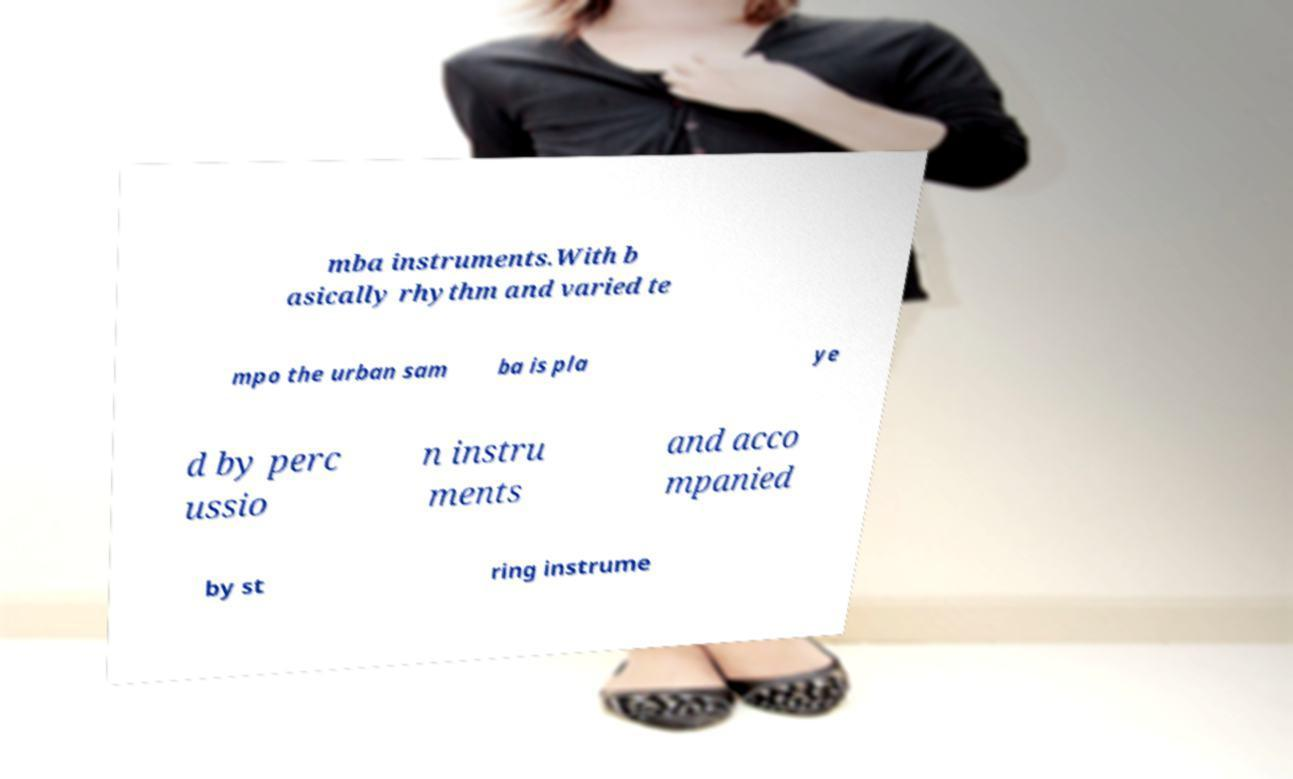For documentation purposes, I need the text within this image transcribed. Could you provide that? mba instruments.With b asically rhythm and varied te mpo the urban sam ba is pla ye d by perc ussio n instru ments and acco mpanied by st ring instrume 